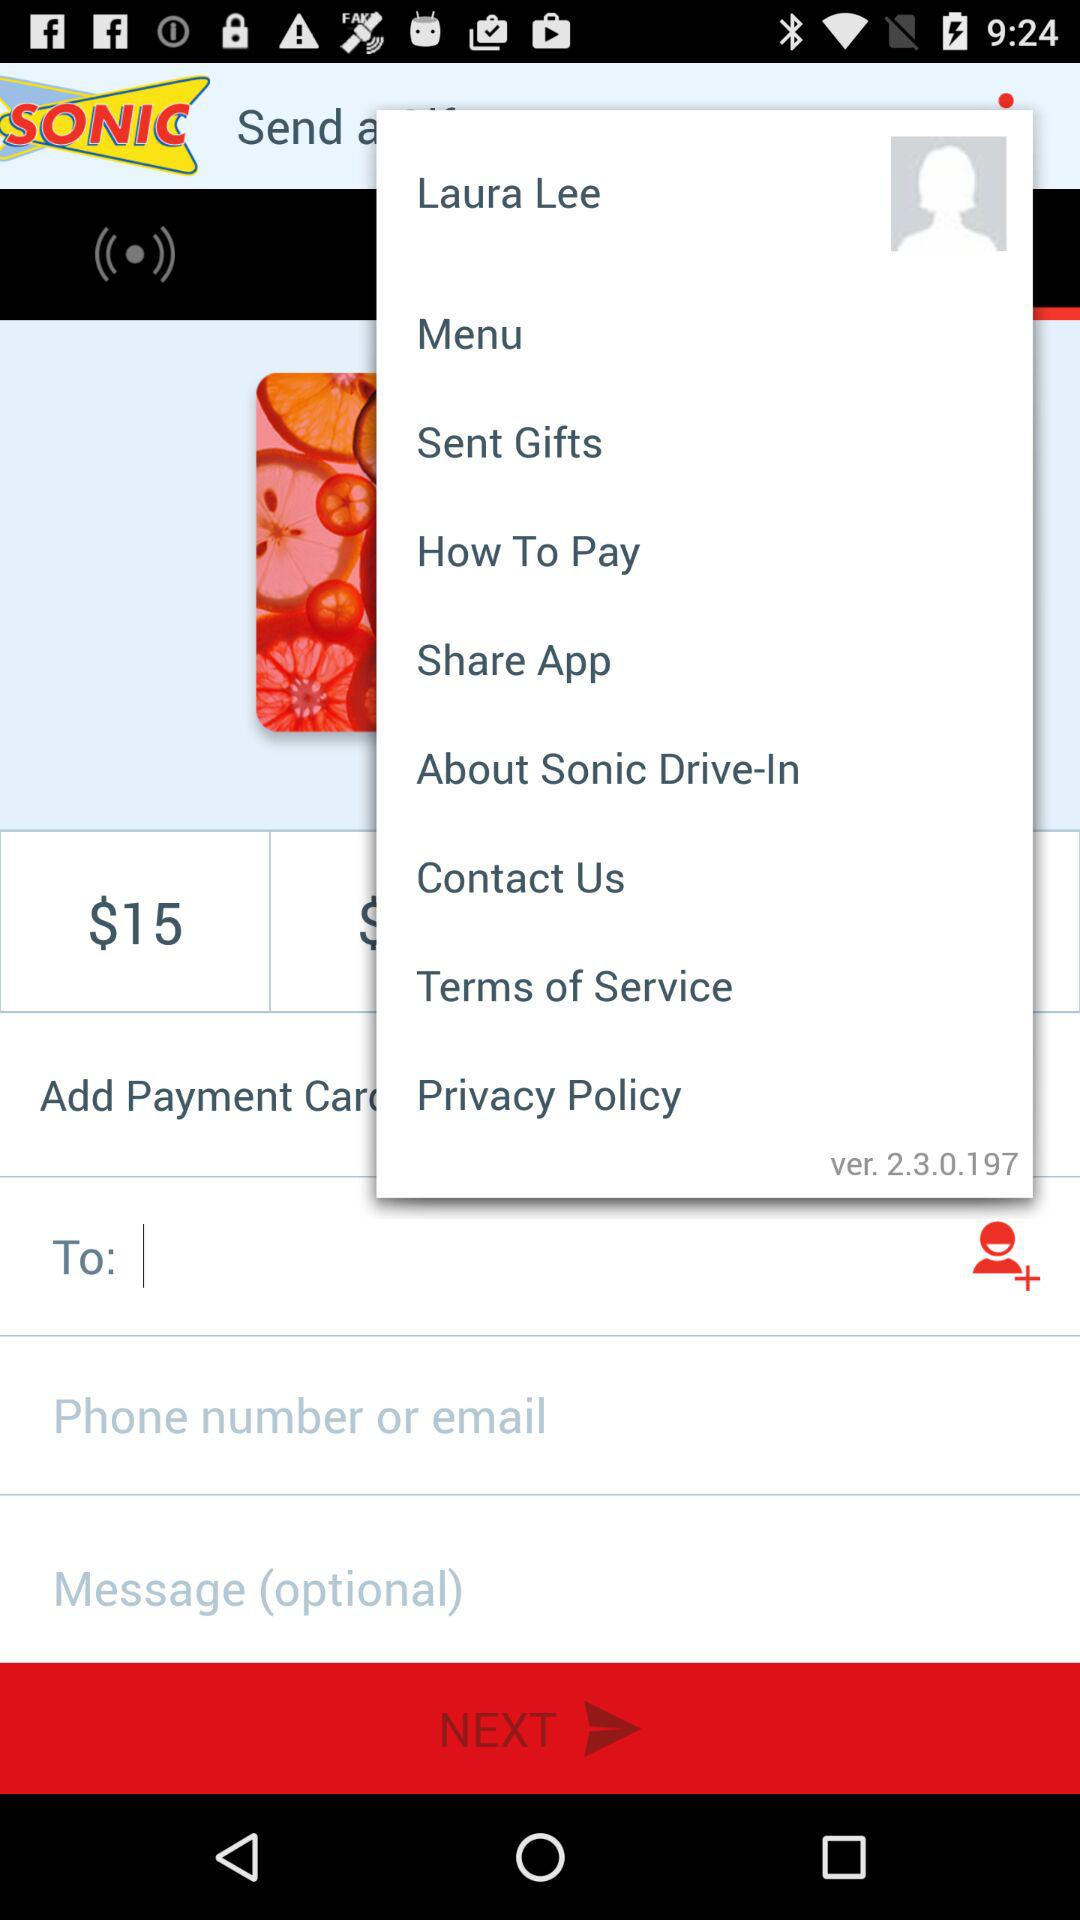What is the version? The version is 2.3.0.197. 